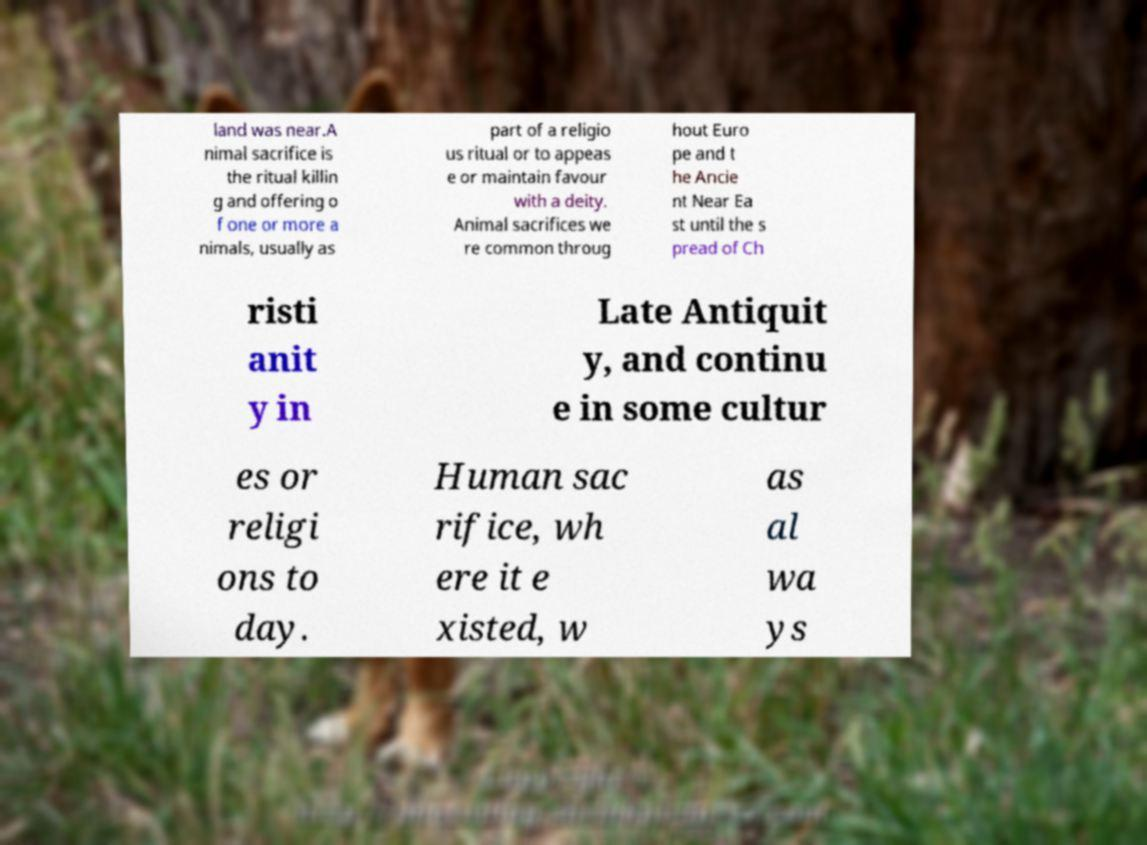For documentation purposes, I need the text within this image transcribed. Could you provide that? land was near.A nimal sacrifice is the ritual killin g and offering o f one or more a nimals, usually as part of a religio us ritual or to appeas e or maintain favour with a deity. Animal sacrifices we re common throug hout Euro pe and t he Ancie nt Near Ea st until the s pread of Ch risti anit y in Late Antiquit y, and continu e in some cultur es or religi ons to day. Human sac rifice, wh ere it e xisted, w as al wa ys 